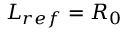<formula> <loc_0><loc_0><loc_500><loc_500>L _ { r e f } = R _ { 0 }</formula> 